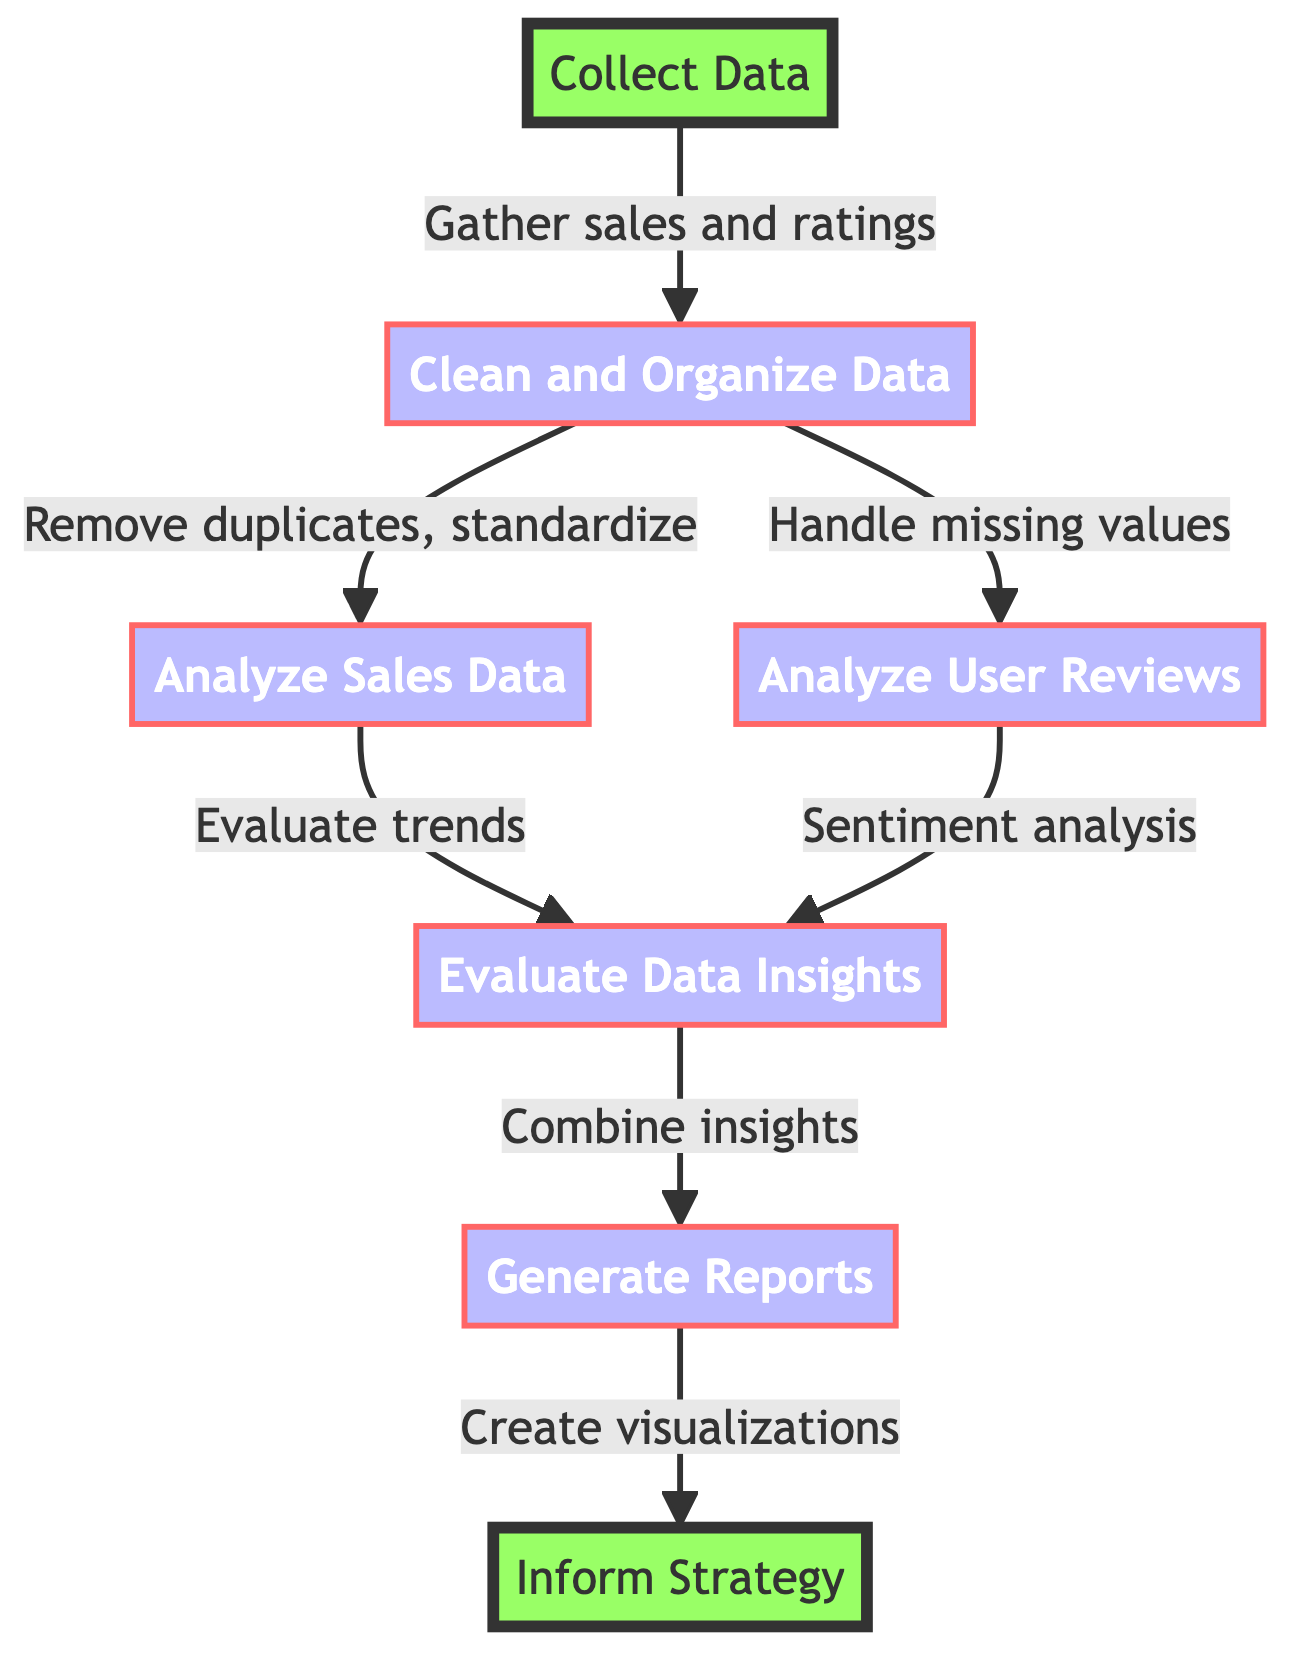What is the first step in the workflow? The first step is "Collect Data," which is the starting node of the flowchart.
Answer: Collect Data How many main processes are there in the workflow? There are five main processes identified in the flowchart: Clean and Organize Data, Analyze Sales Data, Analyze User Reviews, Evaluate Data Insights, and Generate Reports.
Answer: Five Which node follows "Evaluate Data Insights"? The next node that follows "Evaluate Data Insights" is "Generate Reports," indicating that reports are created after combining insights.
Answer: Generate Reports What is the last step in the workflow? The last step is "Inform Strategy," which indicates the conclusion of the entire workflow and the sharing of actionable insights.
Answer: Inform Strategy Which two nodes branch off from "Clean and Organize Data"? The nodes that branch off from "Clean and Organize Data" are "Analyze Sales Data" and "Analyze User Reviews," representing the two paths for further analysis.
Answer: Analyze Sales Data, Analyze User Reviews What type of analysis is performed on user reviews? Sentiment analysis is performed on user reviews to understand user sentiments towards board games, as indicated in the corresponding node.
Answer: Sentiment analysis How are insights combined in this workflow? Insights are combined in the "Evaluate Data Insights" node, which integrates information from both sales data and user reviews to form a comprehensive understanding.
Answer: Combine insights Which node directly influences the "Inform Strategy"? The node that directly influences "Inform Strategy" is "Generate Reports," suggesting that report generation is essential for informing strategy decisions.
Answer: Generate Reports What does the "Clean and Organize Data" node specifically address? The "Clean and Organize Data" node addresses removing duplicates, handling missing values, and standardizing formats to ensure data quality.
Answer: Remove duplicates, handle missing values, standardize formats 